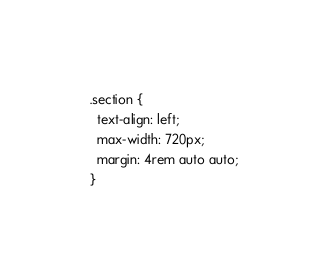Convert code to text. <code><loc_0><loc_0><loc_500><loc_500><_CSS_>
.section {
  text-align: left;
  max-width: 720px;
  margin: 4rem auto auto;
}
</code> 